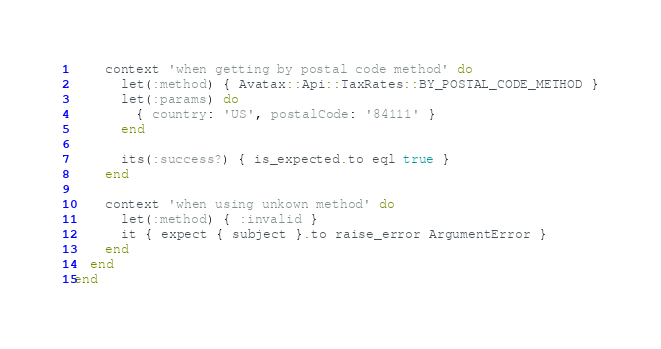<code> <loc_0><loc_0><loc_500><loc_500><_Ruby_>    context 'when getting by postal code method' do
      let(:method) { Avatax::Api::TaxRates::BY_POSTAL_CODE_METHOD }
      let(:params) do
        { country: 'US', postalCode: '84111' }
      end

      its(:success?) { is_expected.to eql true }
    end

    context 'when using unkown method' do
      let(:method) { :invalid }
      it { expect { subject }.to raise_error ArgumentError }
    end
  end
end
</code> 